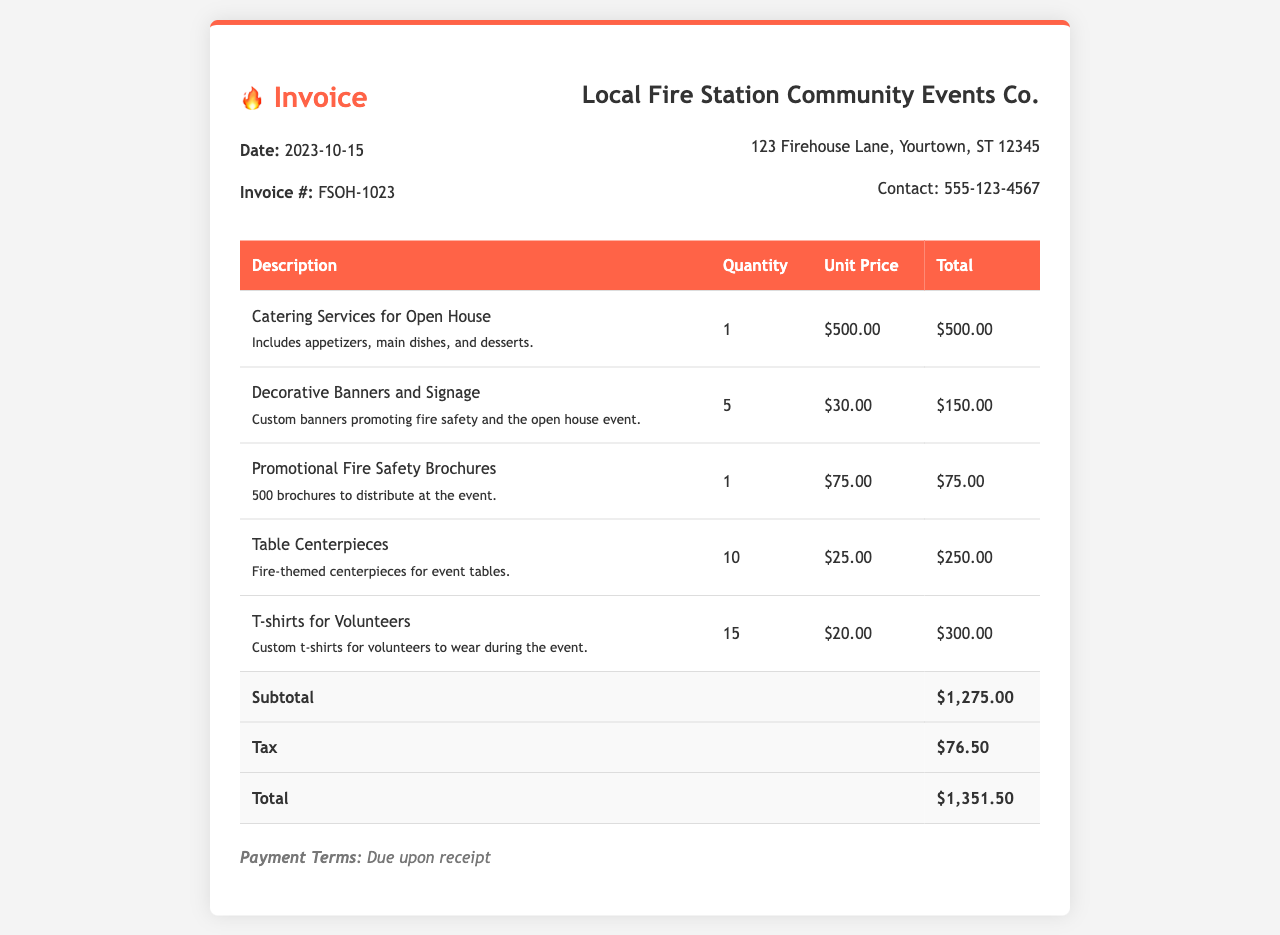What is the date of the invoice? The date of the invoice is specified at the beginning of the document.
Answer: 2023-10-15 What is the invoice number? The invoice number is indicated in the header section of the document.
Answer: FSOH-1023 How many catering services were ordered? The quantity of catering services is listed in the invoice table.
Answer: 1 What is the total amount for decorative banners and signage? The total amount is calculated from the quantity and unit price in the invoice.
Answer: $150.00 What is the subtotal before tax? The subtotal is provided in the total section of the invoice prior to tax addition.
Answer: $1,275.00 What is the tax amount listed in the invoice? The tax amount is specified in the total section of the invoice.
Answer: $76.50 How many promotional fire safety brochures were ordered? The quantity of promotional fire safety brochures is mentioned in the invoice table.
Answer: 1 What is the total cost of T-shirts for volunteers? The total cost is derived from the unit price and quantity listed in the invoice.
Answer: $300.00 What are the payment terms stated in the document? The payment terms are mentioned towards the end of the invoice.
Answer: Due upon receipt 